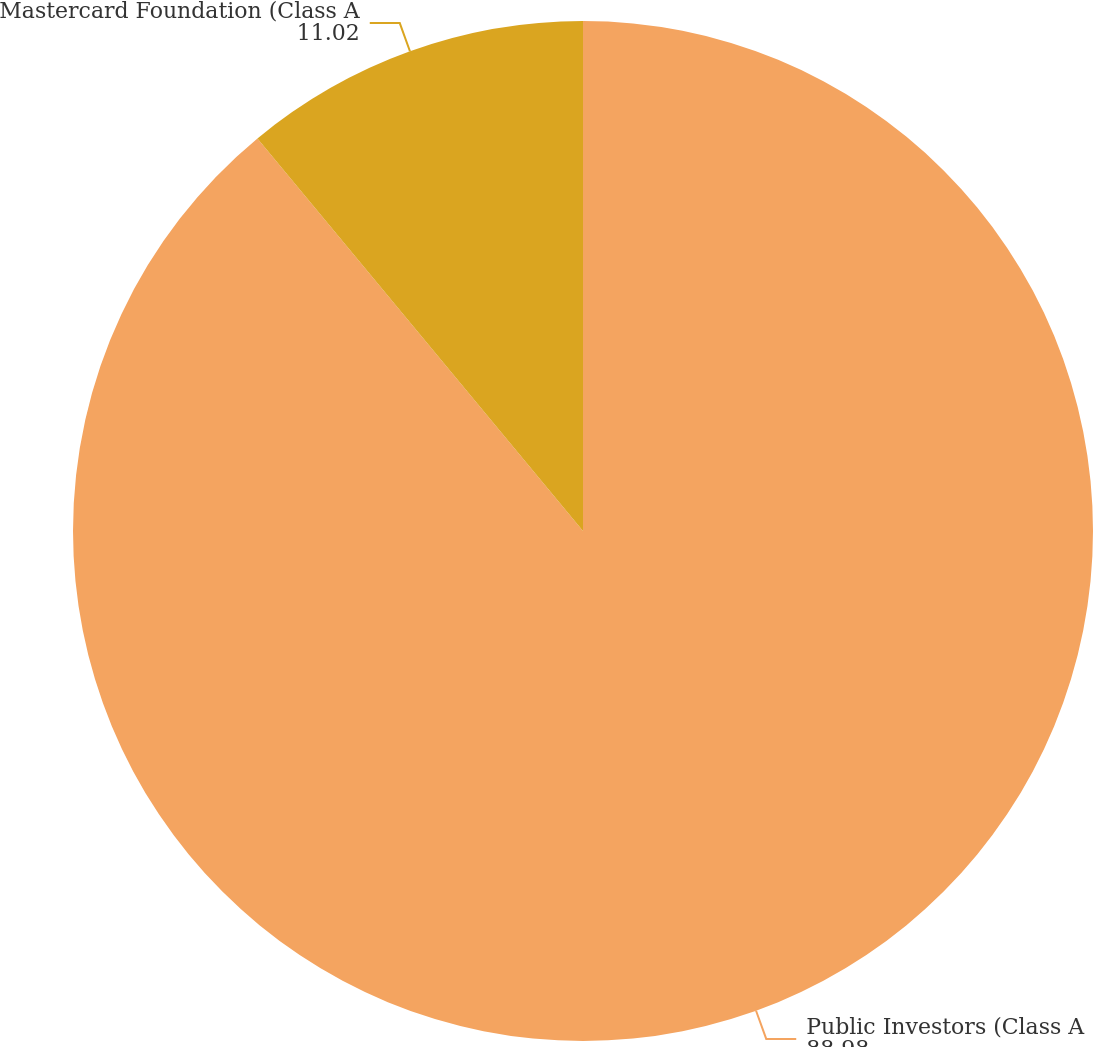Convert chart. <chart><loc_0><loc_0><loc_500><loc_500><pie_chart><fcel>Public Investors (Class A<fcel>Mastercard Foundation (Class A<nl><fcel>88.98%<fcel>11.02%<nl></chart> 